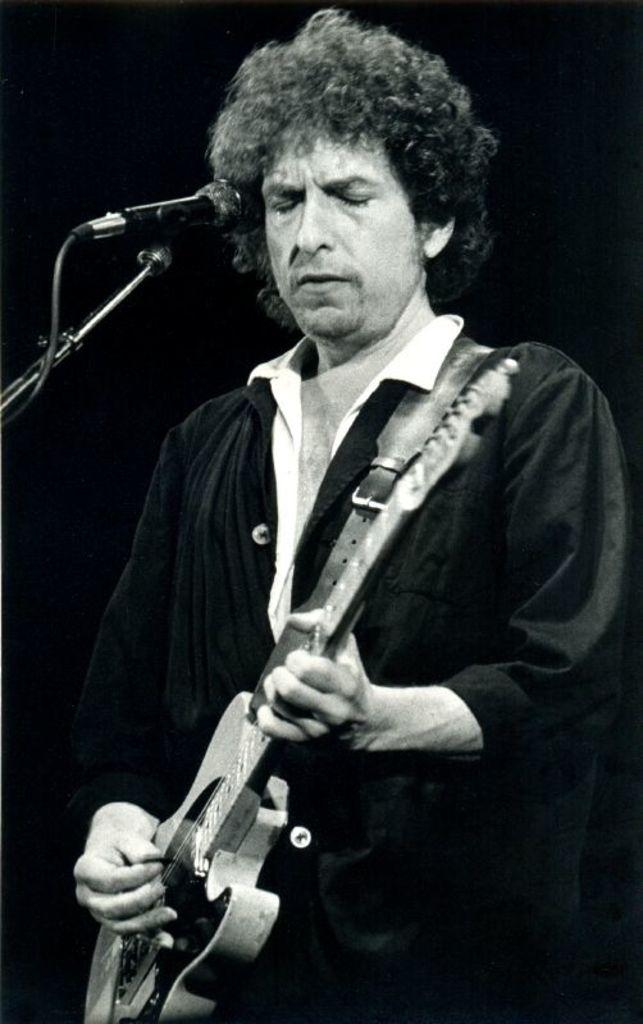What is the main subject of the image? The main subject of the image is a man. What is the man wearing? The man is wearing a black gown. Can you describe the man's hair? The man has curly hair. What is the man doing in the image? The man is standing and playing a guitar with his fingers. What object is beside the man? There is a microphone stand beside him. How does the man keep the hydrant from making noise in the image? There is no hydrant present in the image, so this question cannot be answered. 